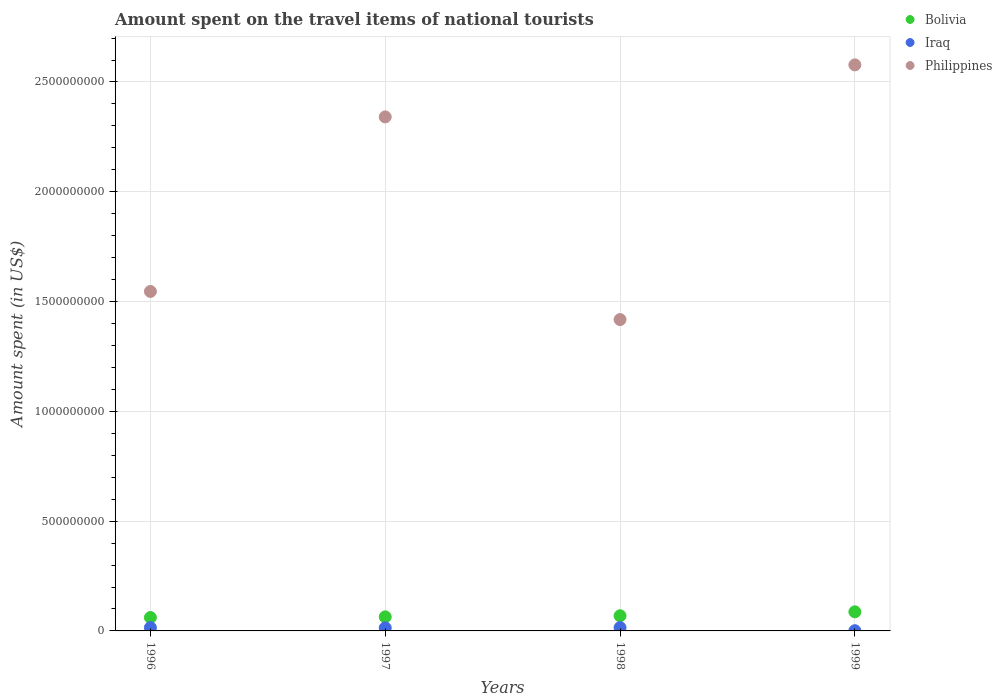How many different coloured dotlines are there?
Your answer should be compact. 3. Is the number of dotlines equal to the number of legend labels?
Ensure brevity in your answer.  Yes. What is the amount spent on the travel items of national tourists in Philippines in 1998?
Offer a terse response. 1.42e+09. Across all years, what is the maximum amount spent on the travel items of national tourists in Bolivia?
Your answer should be very brief. 8.70e+07. In which year was the amount spent on the travel items of national tourists in Bolivia maximum?
Provide a succinct answer. 1999. What is the total amount spent on the travel items of national tourists in Iraq in the graph?
Offer a terse response. 4.50e+07. What is the difference between the amount spent on the travel items of national tourists in Bolivia in 1996 and that in 1997?
Make the answer very short. -3.00e+06. What is the difference between the amount spent on the travel items of national tourists in Philippines in 1997 and the amount spent on the travel items of national tourists in Iraq in 1999?
Offer a very short reply. 2.34e+09. What is the average amount spent on the travel items of national tourists in Bolivia per year?
Keep it short and to the point. 7.02e+07. In the year 1996, what is the difference between the amount spent on the travel items of national tourists in Philippines and amount spent on the travel items of national tourists in Iraq?
Ensure brevity in your answer.  1.53e+09. In how many years, is the amount spent on the travel items of national tourists in Bolivia greater than 2500000000 US$?
Your response must be concise. 0. What is the ratio of the amount spent on the travel items of national tourists in Iraq in 1996 to that in 1997?
Ensure brevity in your answer.  1.07. Is the difference between the amount spent on the travel items of national tourists in Philippines in 1997 and 1998 greater than the difference between the amount spent on the travel items of national tourists in Iraq in 1997 and 1998?
Your response must be concise. Yes. What is the difference between the highest and the lowest amount spent on the travel items of national tourists in Iraq?
Provide a succinct answer. 1.40e+07. Is it the case that in every year, the sum of the amount spent on the travel items of national tourists in Bolivia and amount spent on the travel items of national tourists in Iraq  is greater than the amount spent on the travel items of national tourists in Philippines?
Your answer should be compact. No. Is the amount spent on the travel items of national tourists in Bolivia strictly less than the amount spent on the travel items of national tourists in Iraq over the years?
Your answer should be very brief. No. What is the difference between two consecutive major ticks on the Y-axis?
Give a very brief answer. 5.00e+08. Are the values on the major ticks of Y-axis written in scientific E-notation?
Your answer should be very brief. No. Where does the legend appear in the graph?
Your answer should be compact. Top right. How many legend labels are there?
Provide a short and direct response. 3. What is the title of the graph?
Keep it short and to the point. Amount spent on the travel items of national tourists. Does "Georgia" appear as one of the legend labels in the graph?
Your response must be concise. No. What is the label or title of the Y-axis?
Give a very brief answer. Amount spent (in US$). What is the Amount spent (in US$) of Bolivia in 1996?
Offer a terse response. 6.10e+07. What is the Amount spent (in US$) in Iraq in 1996?
Make the answer very short. 1.50e+07. What is the Amount spent (in US$) of Philippines in 1996?
Offer a terse response. 1.55e+09. What is the Amount spent (in US$) in Bolivia in 1997?
Offer a very short reply. 6.40e+07. What is the Amount spent (in US$) in Iraq in 1997?
Your answer should be compact. 1.40e+07. What is the Amount spent (in US$) in Philippines in 1997?
Give a very brief answer. 2.34e+09. What is the Amount spent (in US$) of Bolivia in 1998?
Give a very brief answer. 6.90e+07. What is the Amount spent (in US$) in Iraq in 1998?
Your answer should be compact. 1.50e+07. What is the Amount spent (in US$) of Philippines in 1998?
Provide a succinct answer. 1.42e+09. What is the Amount spent (in US$) in Bolivia in 1999?
Ensure brevity in your answer.  8.70e+07. What is the Amount spent (in US$) in Iraq in 1999?
Offer a terse response. 1.00e+06. What is the Amount spent (in US$) in Philippines in 1999?
Ensure brevity in your answer.  2.58e+09. Across all years, what is the maximum Amount spent (in US$) of Bolivia?
Provide a short and direct response. 8.70e+07. Across all years, what is the maximum Amount spent (in US$) in Iraq?
Ensure brevity in your answer.  1.50e+07. Across all years, what is the maximum Amount spent (in US$) of Philippines?
Offer a terse response. 2.58e+09. Across all years, what is the minimum Amount spent (in US$) in Bolivia?
Offer a very short reply. 6.10e+07. Across all years, what is the minimum Amount spent (in US$) of Philippines?
Offer a very short reply. 1.42e+09. What is the total Amount spent (in US$) in Bolivia in the graph?
Provide a short and direct response. 2.81e+08. What is the total Amount spent (in US$) of Iraq in the graph?
Ensure brevity in your answer.  4.50e+07. What is the total Amount spent (in US$) of Philippines in the graph?
Offer a terse response. 7.88e+09. What is the difference between the Amount spent (in US$) in Philippines in 1996 and that in 1997?
Give a very brief answer. -7.95e+08. What is the difference between the Amount spent (in US$) in Bolivia in 1996 and that in 1998?
Your answer should be very brief. -8.00e+06. What is the difference between the Amount spent (in US$) in Iraq in 1996 and that in 1998?
Offer a very short reply. 0. What is the difference between the Amount spent (in US$) in Philippines in 1996 and that in 1998?
Offer a very short reply. 1.28e+08. What is the difference between the Amount spent (in US$) in Bolivia in 1996 and that in 1999?
Keep it short and to the point. -2.60e+07. What is the difference between the Amount spent (in US$) in Iraq in 1996 and that in 1999?
Provide a short and direct response. 1.40e+07. What is the difference between the Amount spent (in US$) of Philippines in 1996 and that in 1999?
Keep it short and to the point. -1.03e+09. What is the difference between the Amount spent (in US$) in Bolivia in 1997 and that in 1998?
Provide a succinct answer. -5.00e+06. What is the difference between the Amount spent (in US$) of Philippines in 1997 and that in 1998?
Offer a terse response. 9.23e+08. What is the difference between the Amount spent (in US$) in Bolivia in 1997 and that in 1999?
Ensure brevity in your answer.  -2.30e+07. What is the difference between the Amount spent (in US$) in Iraq in 1997 and that in 1999?
Offer a very short reply. 1.30e+07. What is the difference between the Amount spent (in US$) of Philippines in 1997 and that in 1999?
Offer a terse response. -2.37e+08. What is the difference between the Amount spent (in US$) of Bolivia in 1998 and that in 1999?
Give a very brief answer. -1.80e+07. What is the difference between the Amount spent (in US$) in Iraq in 1998 and that in 1999?
Give a very brief answer. 1.40e+07. What is the difference between the Amount spent (in US$) in Philippines in 1998 and that in 1999?
Offer a very short reply. -1.16e+09. What is the difference between the Amount spent (in US$) in Bolivia in 1996 and the Amount spent (in US$) in Iraq in 1997?
Provide a short and direct response. 4.70e+07. What is the difference between the Amount spent (in US$) of Bolivia in 1996 and the Amount spent (in US$) of Philippines in 1997?
Ensure brevity in your answer.  -2.28e+09. What is the difference between the Amount spent (in US$) in Iraq in 1996 and the Amount spent (in US$) in Philippines in 1997?
Your response must be concise. -2.33e+09. What is the difference between the Amount spent (in US$) in Bolivia in 1996 and the Amount spent (in US$) in Iraq in 1998?
Keep it short and to the point. 4.60e+07. What is the difference between the Amount spent (in US$) in Bolivia in 1996 and the Amount spent (in US$) in Philippines in 1998?
Make the answer very short. -1.36e+09. What is the difference between the Amount spent (in US$) of Iraq in 1996 and the Amount spent (in US$) of Philippines in 1998?
Give a very brief answer. -1.40e+09. What is the difference between the Amount spent (in US$) of Bolivia in 1996 and the Amount spent (in US$) of Iraq in 1999?
Keep it short and to the point. 6.00e+07. What is the difference between the Amount spent (in US$) of Bolivia in 1996 and the Amount spent (in US$) of Philippines in 1999?
Your answer should be compact. -2.52e+09. What is the difference between the Amount spent (in US$) in Iraq in 1996 and the Amount spent (in US$) in Philippines in 1999?
Your answer should be very brief. -2.56e+09. What is the difference between the Amount spent (in US$) of Bolivia in 1997 and the Amount spent (in US$) of Iraq in 1998?
Keep it short and to the point. 4.90e+07. What is the difference between the Amount spent (in US$) of Bolivia in 1997 and the Amount spent (in US$) of Philippines in 1998?
Offer a terse response. -1.35e+09. What is the difference between the Amount spent (in US$) of Iraq in 1997 and the Amount spent (in US$) of Philippines in 1998?
Ensure brevity in your answer.  -1.40e+09. What is the difference between the Amount spent (in US$) of Bolivia in 1997 and the Amount spent (in US$) of Iraq in 1999?
Your response must be concise. 6.30e+07. What is the difference between the Amount spent (in US$) in Bolivia in 1997 and the Amount spent (in US$) in Philippines in 1999?
Your response must be concise. -2.51e+09. What is the difference between the Amount spent (in US$) of Iraq in 1997 and the Amount spent (in US$) of Philippines in 1999?
Your answer should be compact. -2.56e+09. What is the difference between the Amount spent (in US$) in Bolivia in 1998 and the Amount spent (in US$) in Iraq in 1999?
Keep it short and to the point. 6.80e+07. What is the difference between the Amount spent (in US$) of Bolivia in 1998 and the Amount spent (in US$) of Philippines in 1999?
Your response must be concise. -2.51e+09. What is the difference between the Amount spent (in US$) of Iraq in 1998 and the Amount spent (in US$) of Philippines in 1999?
Provide a succinct answer. -2.56e+09. What is the average Amount spent (in US$) of Bolivia per year?
Ensure brevity in your answer.  7.02e+07. What is the average Amount spent (in US$) in Iraq per year?
Your answer should be very brief. 1.12e+07. What is the average Amount spent (in US$) of Philippines per year?
Your response must be concise. 1.97e+09. In the year 1996, what is the difference between the Amount spent (in US$) in Bolivia and Amount spent (in US$) in Iraq?
Give a very brief answer. 4.60e+07. In the year 1996, what is the difference between the Amount spent (in US$) in Bolivia and Amount spent (in US$) in Philippines?
Give a very brief answer. -1.48e+09. In the year 1996, what is the difference between the Amount spent (in US$) of Iraq and Amount spent (in US$) of Philippines?
Your answer should be compact. -1.53e+09. In the year 1997, what is the difference between the Amount spent (in US$) in Bolivia and Amount spent (in US$) in Philippines?
Provide a short and direct response. -2.28e+09. In the year 1997, what is the difference between the Amount spent (in US$) of Iraq and Amount spent (in US$) of Philippines?
Provide a succinct answer. -2.33e+09. In the year 1998, what is the difference between the Amount spent (in US$) of Bolivia and Amount spent (in US$) of Iraq?
Give a very brief answer. 5.40e+07. In the year 1998, what is the difference between the Amount spent (in US$) in Bolivia and Amount spent (in US$) in Philippines?
Your answer should be compact. -1.35e+09. In the year 1998, what is the difference between the Amount spent (in US$) of Iraq and Amount spent (in US$) of Philippines?
Give a very brief answer. -1.40e+09. In the year 1999, what is the difference between the Amount spent (in US$) in Bolivia and Amount spent (in US$) in Iraq?
Ensure brevity in your answer.  8.60e+07. In the year 1999, what is the difference between the Amount spent (in US$) of Bolivia and Amount spent (in US$) of Philippines?
Your response must be concise. -2.49e+09. In the year 1999, what is the difference between the Amount spent (in US$) of Iraq and Amount spent (in US$) of Philippines?
Keep it short and to the point. -2.58e+09. What is the ratio of the Amount spent (in US$) in Bolivia in 1996 to that in 1997?
Your answer should be compact. 0.95. What is the ratio of the Amount spent (in US$) in Iraq in 1996 to that in 1997?
Make the answer very short. 1.07. What is the ratio of the Amount spent (in US$) in Philippines in 1996 to that in 1997?
Your answer should be very brief. 0.66. What is the ratio of the Amount spent (in US$) of Bolivia in 1996 to that in 1998?
Ensure brevity in your answer.  0.88. What is the ratio of the Amount spent (in US$) of Philippines in 1996 to that in 1998?
Provide a short and direct response. 1.09. What is the ratio of the Amount spent (in US$) of Bolivia in 1996 to that in 1999?
Your response must be concise. 0.7. What is the ratio of the Amount spent (in US$) in Philippines in 1996 to that in 1999?
Ensure brevity in your answer.  0.6. What is the ratio of the Amount spent (in US$) of Bolivia in 1997 to that in 1998?
Provide a succinct answer. 0.93. What is the ratio of the Amount spent (in US$) of Philippines in 1997 to that in 1998?
Offer a terse response. 1.65. What is the ratio of the Amount spent (in US$) of Bolivia in 1997 to that in 1999?
Keep it short and to the point. 0.74. What is the ratio of the Amount spent (in US$) of Iraq in 1997 to that in 1999?
Keep it short and to the point. 14. What is the ratio of the Amount spent (in US$) of Philippines in 1997 to that in 1999?
Provide a short and direct response. 0.91. What is the ratio of the Amount spent (in US$) in Bolivia in 1998 to that in 1999?
Your response must be concise. 0.79. What is the ratio of the Amount spent (in US$) in Iraq in 1998 to that in 1999?
Provide a succinct answer. 15. What is the ratio of the Amount spent (in US$) of Philippines in 1998 to that in 1999?
Offer a very short reply. 0.55. What is the difference between the highest and the second highest Amount spent (in US$) in Bolivia?
Your response must be concise. 1.80e+07. What is the difference between the highest and the second highest Amount spent (in US$) of Iraq?
Provide a short and direct response. 0. What is the difference between the highest and the second highest Amount spent (in US$) in Philippines?
Make the answer very short. 2.37e+08. What is the difference between the highest and the lowest Amount spent (in US$) of Bolivia?
Ensure brevity in your answer.  2.60e+07. What is the difference between the highest and the lowest Amount spent (in US$) of Iraq?
Your response must be concise. 1.40e+07. What is the difference between the highest and the lowest Amount spent (in US$) in Philippines?
Give a very brief answer. 1.16e+09. 